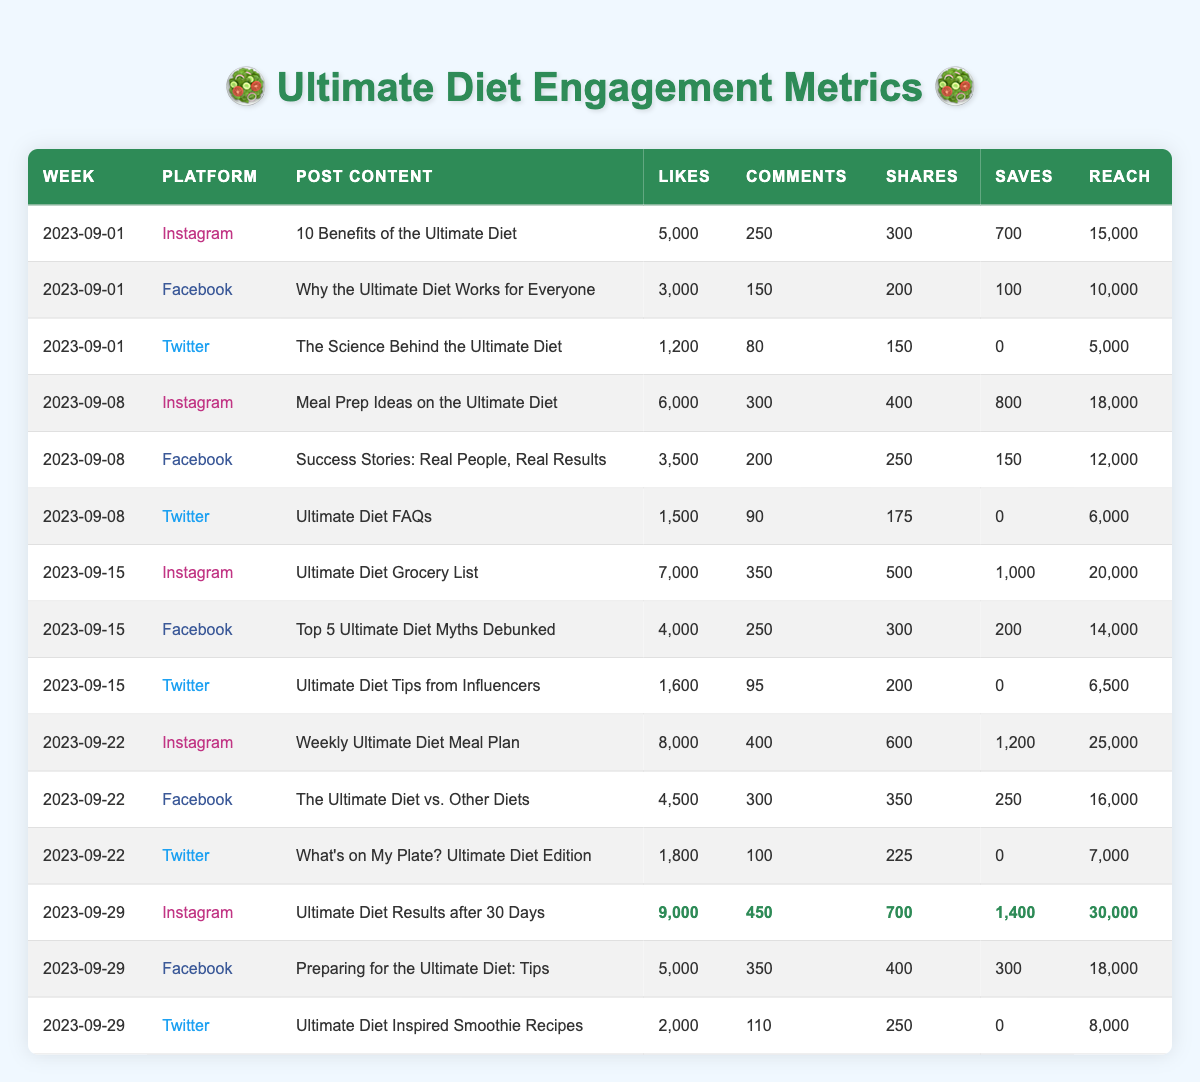What social media platform had the highest engagement in terms of likes on September 29, 2023? On September 29, 2023, the Instagram post titled "Ultimate Diet Results after 30 Days" received 9,000 likes, more than any other platform or post that week.
Answer: Instagram What was the total number of comments across all platforms for the week of September 15, 2023? For September 15, 2023, the comments were: Instagram (350) + Facebook (250) + Twitter (95) = 695. Therefore, the total is 695 comments.
Answer: 695 Did any posts on Twitter during the weeks listed have more likes than the corresponding Instagram posts? Reviewing the Twitter posts shows that none had more likes than their Instagram counterparts; the highest Twitter post received 2,000 likes compared to Instagram's 9,000 likes on the same day.
Answer: No Which week had the highest average reach across all platforms? The reach for each week is: Week of September 1: (15,000 + 10,000 + 5,000) / 3 = 10,000; September 8: (18,000 + 12,000 + 6,000) / 3 = 12,000; September 15: (20,000 + 14,000 + 6,500) / 3 = 13,500; September 22: (25,000 + 16,000 + 7,000) / 3 = 16,000; September 29: (30,000 + 18,000 + 8,000) / 3 = 18,667. The highest average reach is 18,667 on September 29.
Answer: September 29 What percentage of total shares did the Instagram post "Ultimate Diet Results after 30 Days" achieve among all posts for that week? The total shares for that week are: Instagram (700) + Facebook (400) + Twitter (250) = 1350. The Instagram post had 700 shares, which is (700 / 1350) * 100 = 51.85%.
Answer: 51.85% Which post had the least number of saves, and which platform was it on? In the data provided, the Twitter post titled "The Science Behind the Ultimate Diet" had 0 saves, making it the one with the least.
Answer: Twitter post "The Science Behind the Ultimate Diet" What is the total number of likes across all platforms for the week of September 22, 2023? The total likes are: Instagram (8,000) + Facebook (4,500) + Twitter (1,800) = 14,300. Therefore, the total likes for that week is 14,300.
Answer: 14,300 Which post on Facebook had the highest engagement, measured by the sum of likes, comments, shares, and saves? For Facebook posts, the highest engagement post is "Preparing for the Ultimate Diet: Tips" with 5,000 likes, 350 comments, 400 shares, and 300 saves, totaling 6,050.
Answer: "Preparing for the Ultimate Diet: Tips" How much more reach did the Instagram post on September 29 compared to the Facebook post on the same day? The reach for the Instagram post "Ultimate Diet Results after 30 Days" is 30,000 and the Facebook post "Preparing for the Ultimate Diet: Tips" is 18,000. The difference is 30,000 - 18,000 = 12,000.
Answer: 12,000 What was the trend in the number of likes on Instagram posts from week to week? Reviewing the Instagram likes: Week of September 1 (5,000), September 8 (6,000), September 15 (7,000), September 22 (8,000), September 29 (9,000) shows a consistent increase of 1,000 likes each week.
Answer: Increasing Which platform consistently had the lowest engagement across all weeks in terms of likes? Looking at the data, Twitter consistently had the lowest likes compared to Instagram and Facebook in all weeks, with the highest being only 2,000 on September 29.
Answer: Twitter 